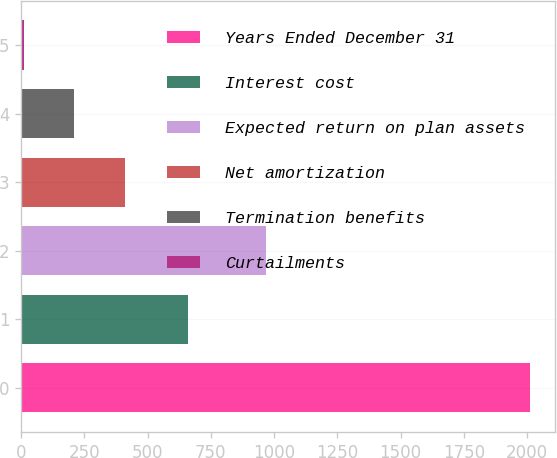Convert chart to OTSL. <chart><loc_0><loc_0><loc_500><loc_500><bar_chart><fcel>Years Ended December 31<fcel>Interest cost<fcel>Expected return on plan assets<fcel>Net amortization<fcel>Termination benefits<fcel>Curtailments<nl><fcel>2012<fcel>661<fcel>970<fcel>410.4<fcel>210.2<fcel>10<nl></chart> 